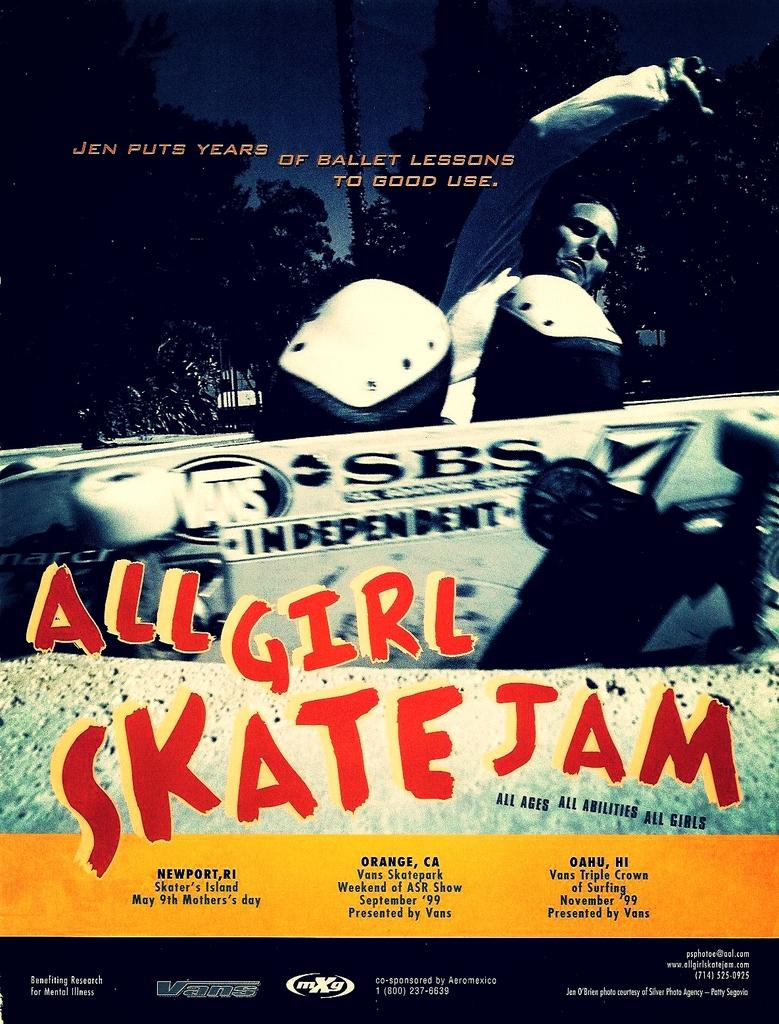<image>
Share a concise interpretation of the image provided. A poster for All Girl Skate Jam that shows the locations that it will be happening. 